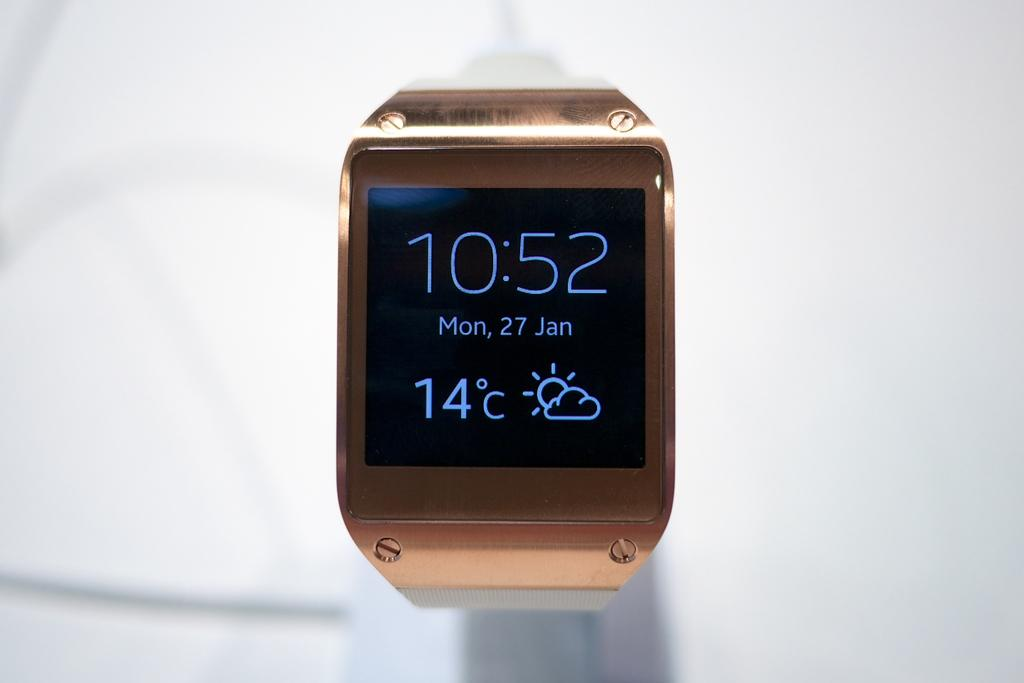<image>
Render a clear and concise summary of the photo. Rose gold smart watch with black face and light blue display numbers, showing current temperature at 14 degrees Celsius, partially sunny on Monday, January 27th at 10:52. 